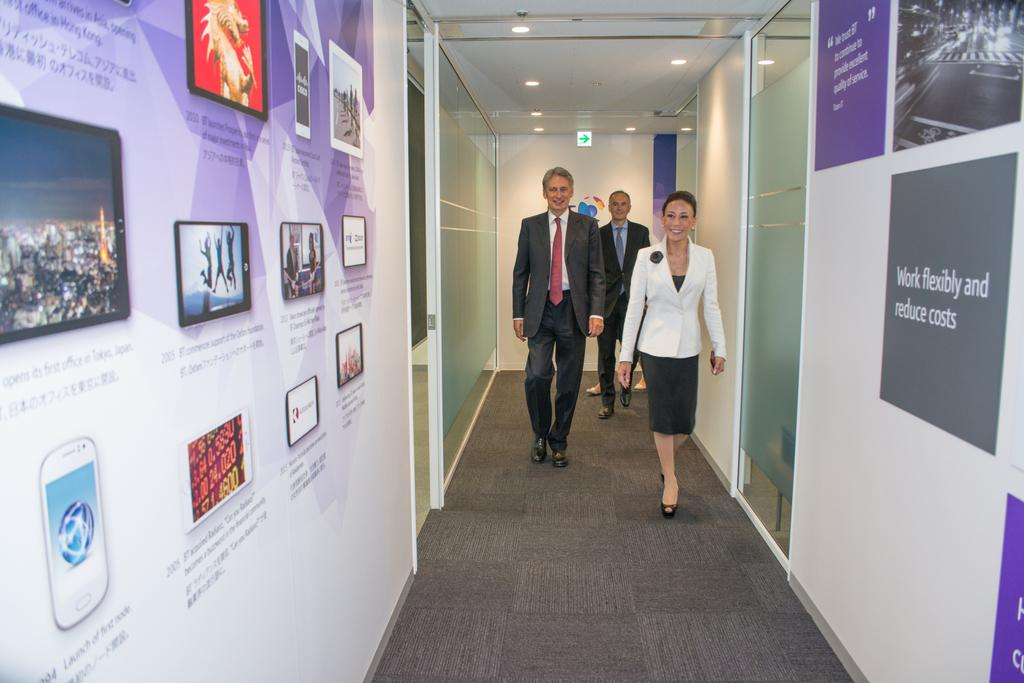<image>
Provide a brief description of the given image. Several images printed on the walls with one image saying "Work flexibly and reduce costs" 